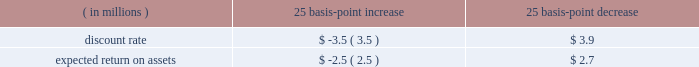We also record an inventory obsolescence reserve , which represents the difference between the cost of the inventory and its estimated realizable value , based on various product sales projections .
This reserve is calcu- lated using an estimated obsolescence percentage applied to the inventory based on age , historical trends and requirements to support forecasted sales .
In addition , and as necessary , we may establish specific reserves for future known or anticipated events .
Pension and other post-retirement benefit costs we offer the following benefits to some or all of our employees : a domestic trust-based noncontributory qual- ified defined benefit pension plan ( 201cu.s .
Qualified plan 201d ) and an unfunded , non-qualified domestic noncon- tributory pension plan to provide benefits in excess of statutory limitations ( collectively with the u.s .
Qualified plan , the 201cdomestic plans 201d ) ; a domestic contributory defined contribution plan ; international pension plans , which vary by country , consisting of both defined benefit and defined contribution pension plans ; deferred compensation arrangements ; and certain other post- retirement benefit plans .
The amounts needed to fund future payouts under our defined benefit pension and post-retirement benefit plans are subject to numerous assumptions and variables .
Cer- tain significant variables require us to make assumptions that are within our control such as an anticipated discount rate , expected rate of return on plan assets and future compensation levels .
We evaluate these assumptions with our actuarial advisors and select assumptions that we believe reflect the economics underlying our pension and post-retirement obligations .
While we believe these assumptions are within accepted industry ranges , an increase or decrease in the assumptions or economic events outside our control could have a direct impact on reported net earnings .
The discount rate for each plan used for determining future net periodic benefit cost is based on a review of highly rated long-term bonds .
For fiscal 2013 , we used a discount rate for our domestic plans of 3.90% ( 3.90 % ) and vary- ing rates on our international plans of between 1.00% ( 1.00 % ) and 7.00% ( 7.00 % ) .
The discount rate for our domestic plans is based on a bond portfolio that includes only long-term bonds with an aa rating , or equivalent , from a major rating agency .
As of june 30 , 2013 , we used an above-mean yield curve , rather than the broad-based yield curve we used before , because we believe it represents a better estimate of an effective settlement rate of the obligation , and the timing and amount of cash flows related to the bonds included in this portfolio are expected to match the estimated defined benefit payment streams of our domestic plans .
The benefit obligation of our domestic plans would have been higher by approximately $ 34 mil- lion at june 30 , 2013 had we not used the above-mean yield curve .
For our international plans , the discount rate in a particular country was principally determined based on a yield curve constructed from high quality corporate bonds in each country , with the resulting portfolio having a duration matching that particular plan .
For fiscal 2013 , we used an expected return on plan assets of 7.50% ( 7.50 % ) for our u.s .
Qualified plan and varying rates of between 2.25% ( 2.25 % ) and 7.00% ( 7.00 % ) for our international plans .
In determining the long-term rate of return for a plan , we consider the historical rates of return , the nature of the plan 2019s investments and an expectation for the plan 2019s investment strategies .
See 201cnote 12 2014 pension , deferred compensation and post-retirement benefit plans 201d of notes to consolidated financial statements for details regarding the nature of our pension and post-retirement plan invest- ments .
The difference between actual and expected return on plan assets is reported as a component of accu- mulated other comprehensive income .
Those gains/losses that are subject to amortization over future periods will be recognized as a component of the net periodic benefit cost in such future periods .
For fiscal 2013 , our pension plans had actual return on assets of approximately $ 74 million as compared with expected return on assets of approximately $ 64 million .
The resulting net deferred gain of approximately $ 10 million , when combined with gains and losses from previous years , will be amortized over periods ranging from approximately 7 to 22 years .
The actual return on plan assets from our international pen- sion plans exceeded expectations , primarily reflecting a strong performance from fixed income and equity invest- ments .
The lower than expected return on assets from our u.s .
Qualified plan was primarily due to weakness in our fixed income investments , partially offset by our strong equity returns .
A 25 basis-point change in the discount rate or the expected rate of return on plan assets would have had the following effect on fiscal 2013 pension expense : 25 basis-point 25 basis-point increase decrease ( in millions ) .
Our post-retirement plans are comprised of health care plans that could be impacted by health care cost trend rates , which may have a significant effect on the amounts the est{e lauder companies inc .
115 .
What is the average rate for the international plans? 
Rationale: it is the sum of the rates divided by two .
Computations: ((2.25% + 7.00%) / 2)
Answer: 0.04625. 